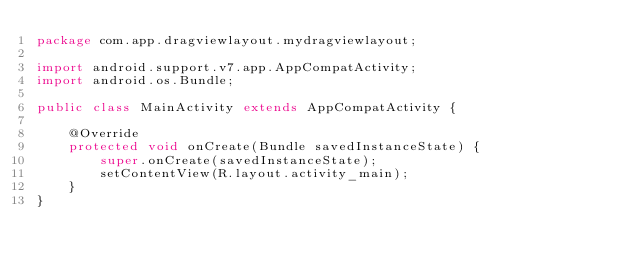<code> <loc_0><loc_0><loc_500><loc_500><_Java_>package com.app.dragviewlayout.mydragviewlayout;

import android.support.v7.app.AppCompatActivity;
import android.os.Bundle;

public class MainActivity extends AppCompatActivity {

    @Override
    protected void onCreate(Bundle savedInstanceState) {
        super.onCreate(savedInstanceState);
        setContentView(R.layout.activity_main);
    }
}
</code> 